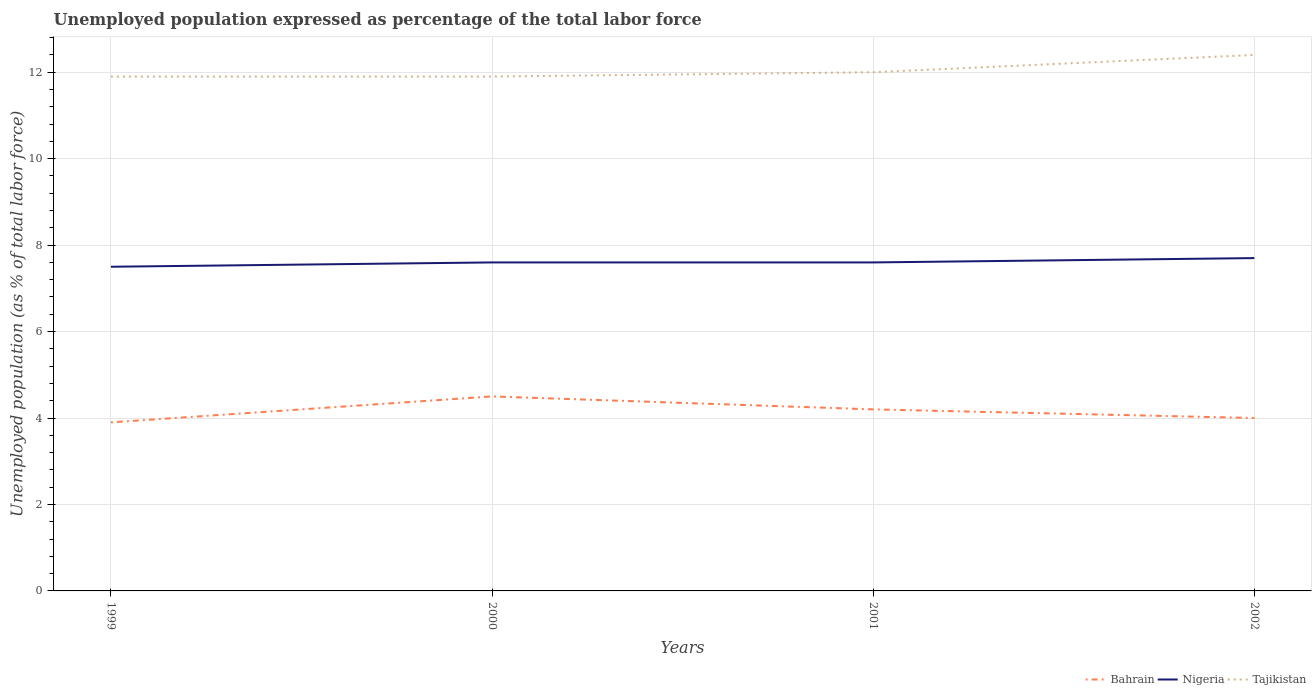How many different coloured lines are there?
Offer a terse response. 3. Does the line corresponding to Bahrain intersect with the line corresponding to Nigeria?
Provide a short and direct response. No. Across all years, what is the maximum unemployment in in Bahrain?
Offer a very short reply. 3.9. What is the total unemployment in in Nigeria in the graph?
Your answer should be compact. -0.1. What is the difference between the highest and the second highest unemployment in in Nigeria?
Your answer should be very brief. 0.2. What is the difference between the highest and the lowest unemployment in in Nigeria?
Offer a very short reply. 1. Is the unemployment in in Tajikistan strictly greater than the unemployment in in Nigeria over the years?
Your answer should be compact. No. How many years are there in the graph?
Give a very brief answer. 4. What is the title of the graph?
Your answer should be very brief. Unemployed population expressed as percentage of the total labor force. Does "Rwanda" appear as one of the legend labels in the graph?
Your response must be concise. No. What is the label or title of the X-axis?
Give a very brief answer. Years. What is the label or title of the Y-axis?
Offer a terse response. Unemployed population (as % of total labor force). What is the Unemployed population (as % of total labor force) in Bahrain in 1999?
Offer a terse response. 3.9. What is the Unemployed population (as % of total labor force) in Nigeria in 1999?
Keep it short and to the point. 7.5. What is the Unemployed population (as % of total labor force) in Tajikistan in 1999?
Your response must be concise. 11.9. What is the Unemployed population (as % of total labor force) of Bahrain in 2000?
Make the answer very short. 4.5. What is the Unemployed population (as % of total labor force) of Nigeria in 2000?
Your answer should be compact. 7.6. What is the Unemployed population (as % of total labor force) in Tajikistan in 2000?
Your answer should be compact. 11.9. What is the Unemployed population (as % of total labor force) in Bahrain in 2001?
Provide a succinct answer. 4.2. What is the Unemployed population (as % of total labor force) in Nigeria in 2001?
Your response must be concise. 7.6. What is the Unemployed population (as % of total labor force) of Bahrain in 2002?
Offer a very short reply. 4. What is the Unemployed population (as % of total labor force) of Nigeria in 2002?
Your answer should be compact. 7.7. What is the Unemployed population (as % of total labor force) of Tajikistan in 2002?
Your answer should be very brief. 12.4. Across all years, what is the maximum Unemployed population (as % of total labor force) in Bahrain?
Make the answer very short. 4.5. Across all years, what is the maximum Unemployed population (as % of total labor force) in Nigeria?
Offer a terse response. 7.7. Across all years, what is the maximum Unemployed population (as % of total labor force) in Tajikistan?
Offer a terse response. 12.4. Across all years, what is the minimum Unemployed population (as % of total labor force) of Bahrain?
Offer a terse response. 3.9. Across all years, what is the minimum Unemployed population (as % of total labor force) of Tajikistan?
Offer a very short reply. 11.9. What is the total Unemployed population (as % of total labor force) in Bahrain in the graph?
Offer a very short reply. 16.6. What is the total Unemployed population (as % of total labor force) of Nigeria in the graph?
Your answer should be compact. 30.4. What is the total Unemployed population (as % of total labor force) in Tajikistan in the graph?
Offer a very short reply. 48.2. What is the difference between the Unemployed population (as % of total labor force) in Nigeria in 1999 and that in 2000?
Provide a succinct answer. -0.1. What is the difference between the Unemployed population (as % of total labor force) in Tajikistan in 1999 and that in 2000?
Give a very brief answer. 0. What is the difference between the Unemployed population (as % of total labor force) of Nigeria in 1999 and that in 2001?
Ensure brevity in your answer.  -0.1. What is the difference between the Unemployed population (as % of total labor force) of Bahrain in 1999 and that in 2002?
Your answer should be compact. -0.1. What is the difference between the Unemployed population (as % of total labor force) of Nigeria in 1999 and that in 2002?
Provide a short and direct response. -0.2. What is the difference between the Unemployed population (as % of total labor force) of Bahrain in 2000 and that in 2002?
Offer a very short reply. 0.5. What is the difference between the Unemployed population (as % of total labor force) in Tajikistan in 2000 and that in 2002?
Provide a succinct answer. -0.5. What is the difference between the Unemployed population (as % of total labor force) in Bahrain in 2001 and that in 2002?
Provide a short and direct response. 0.2. What is the difference between the Unemployed population (as % of total labor force) in Bahrain in 1999 and the Unemployed population (as % of total labor force) in Nigeria in 2000?
Give a very brief answer. -3.7. What is the difference between the Unemployed population (as % of total labor force) in Bahrain in 1999 and the Unemployed population (as % of total labor force) in Tajikistan in 2000?
Keep it short and to the point. -8. What is the difference between the Unemployed population (as % of total labor force) of Bahrain in 1999 and the Unemployed population (as % of total labor force) of Nigeria in 2001?
Provide a short and direct response. -3.7. What is the difference between the Unemployed population (as % of total labor force) in Bahrain in 1999 and the Unemployed population (as % of total labor force) in Tajikistan in 2001?
Provide a succinct answer. -8.1. What is the difference between the Unemployed population (as % of total labor force) of Bahrain in 1999 and the Unemployed population (as % of total labor force) of Tajikistan in 2002?
Provide a short and direct response. -8.5. What is the difference between the Unemployed population (as % of total labor force) of Bahrain in 2000 and the Unemployed population (as % of total labor force) of Nigeria in 2001?
Offer a terse response. -3.1. What is the difference between the Unemployed population (as % of total labor force) in Nigeria in 2000 and the Unemployed population (as % of total labor force) in Tajikistan in 2002?
Your response must be concise. -4.8. What is the difference between the Unemployed population (as % of total labor force) in Bahrain in 2001 and the Unemployed population (as % of total labor force) in Nigeria in 2002?
Your answer should be very brief. -3.5. What is the average Unemployed population (as % of total labor force) in Bahrain per year?
Provide a succinct answer. 4.15. What is the average Unemployed population (as % of total labor force) in Nigeria per year?
Provide a succinct answer. 7.6. What is the average Unemployed population (as % of total labor force) of Tajikistan per year?
Provide a succinct answer. 12.05. In the year 1999, what is the difference between the Unemployed population (as % of total labor force) of Bahrain and Unemployed population (as % of total labor force) of Nigeria?
Provide a succinct answer. -3.6. In the year 1999, what is the difference between the Unemployed population (as % of total labor force) of Bahrain and Unemployed population (as % of total labor force) of Tajikistan?
Ensure brevity in your answer.  -8. In the year 2000, what is the difference between the Unemployed population (as % of total labor force) of Bahrain and Unemployed population (as % of total labor force) of Nigeria?
Make the answer very short. -3.1. In the year 2000, what is the difference between the Unemployed population (as % of total labor force) of Bahrain and Unemployed population (as % of total labor force) of Tajikistan?
Give a very brief answer. -7.4. In the year 2001, what is the difference between the Unemployed population (as % of total labor force) of Bahrain and Unemployed population (as % of total labor force) of Tajikistan?
Your response must be concise. -7.8. In the year 2001, what is the difference between the Unemployed population (as % of total labor force) of Nigeria and Unemployed population (as % of total labor force) of Tajikistan?
Provide a succinct answer. -4.4. In the year 2002, what is the difference between the Unemployed population (as % of total labor force) of Bahrain and Unemployed population (as % of total labor force) of Nigeria?
Your response must be concise. -3.7. In the year 2002, what is the difference between the Unemployed population (as % of total labor force) of Nigeria and Unemployed population (as % of total labor force) of Tajikistan?
Your response must be concise. -4.7. What is the ratio of the Unemployed population (as % of total labor force) of Bahrain in 1999 to that in 2000?
Keep it short and to the point. 0.87. What is the ratio of the Unemployed population (as % of total labor force) of Nigeria in 1999 to that in 2000?
Your response must be concise. 0.99. What is the ratio of the Unemployed population (as % of total labor force) in Nigeria in 1999 to that in 2001?
Give a very brief answer. 0.99. What is the ratio of the Unemployed population (as % of total labor force) of Nigeria in 1999 to that in 2002?
Ensure brevity in your answer.  0.97. What is the ratio of the Unemployed population (as % of total labor force) of Tajikistan in 1999 to that in 2002?
Your answer should be very brief. 0.96. What is the ratio of the Unemployed population (as % of total labor force) in Bahrain in 2000 to that in 2001?
Provide a succinct answer. 1.07. What is the ratio of the Unemployed population (as % of total labor force) in Tajikistan in 2000 to that in 2002?
Provide a succinct answer. 0.96. What is the ratio of the Unemployed population (as % of total labor force) of Bahrain in 2001 to that in 2002?
Give a very brief answer. 1.05. What is the ratio of the Unemployed population (as % of total labor force) in Nigeria in 2001 to that in 2002?
Ensure brevity in your answer.  0.99. What is the difference between the highest and the lowest Unemployed population (as % of total labor force) in Bahrain?
Provide a succinct answer. 0.6. 